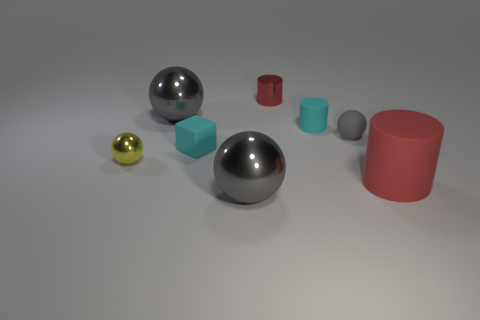What is the tiny red cylinder made of?
Give a very brief answer. Metal. There is a tiny red object that is the same shape as the large red matte object; what material is it?
Your response must be concise. Metal. There is a cube behind the big metallic object in front of the yellow metal thing; what color is it?
Offer a very short reply. Cyan. What number of shiny objects are large things or small green balls?
Give a very brief answer. 2. Is the material of the small cyan block the same as the cyan cylinder?
Offer a very short reply. Yes. What material is the ball that is right of the gray shiny object in front of the tiny yellow ball?
Your answer should be very brief. Rubber. How many large things are either gray shiny objects or matte blocks?
Your answer should be compact. 2. What is the size of the red matte cylinder?
Keep it short and to the point. Large. Is the number of gray objects to the left of the small metallic cylinder greater than the number of red rubber things?
Give a very brief answer. Yes. Are there an equal number of large gray shiny objects that are behind the big red rubber cylinder and tiny objects behind the small metallic sphere?
Give a very brief answer. No. 